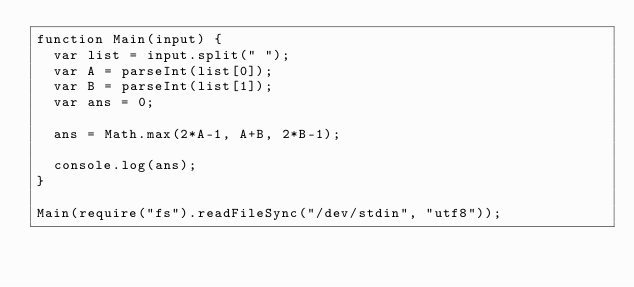<code> <loc_0><loc_0><loc_500><loc_500><_JavaScript_>function Main(input) {
  var list = input.split(" ");
  var A = parseInt(list[0]);
  var B = parseInt(list[1]);
  var ans = 0;
  
  ans = Math.max(2*A-1, A+B, 2*B-1);
  
  console.log(ans);
}
 
Main(require("fs").readFileSync("/dev/stdin", "utf8"));</code> 